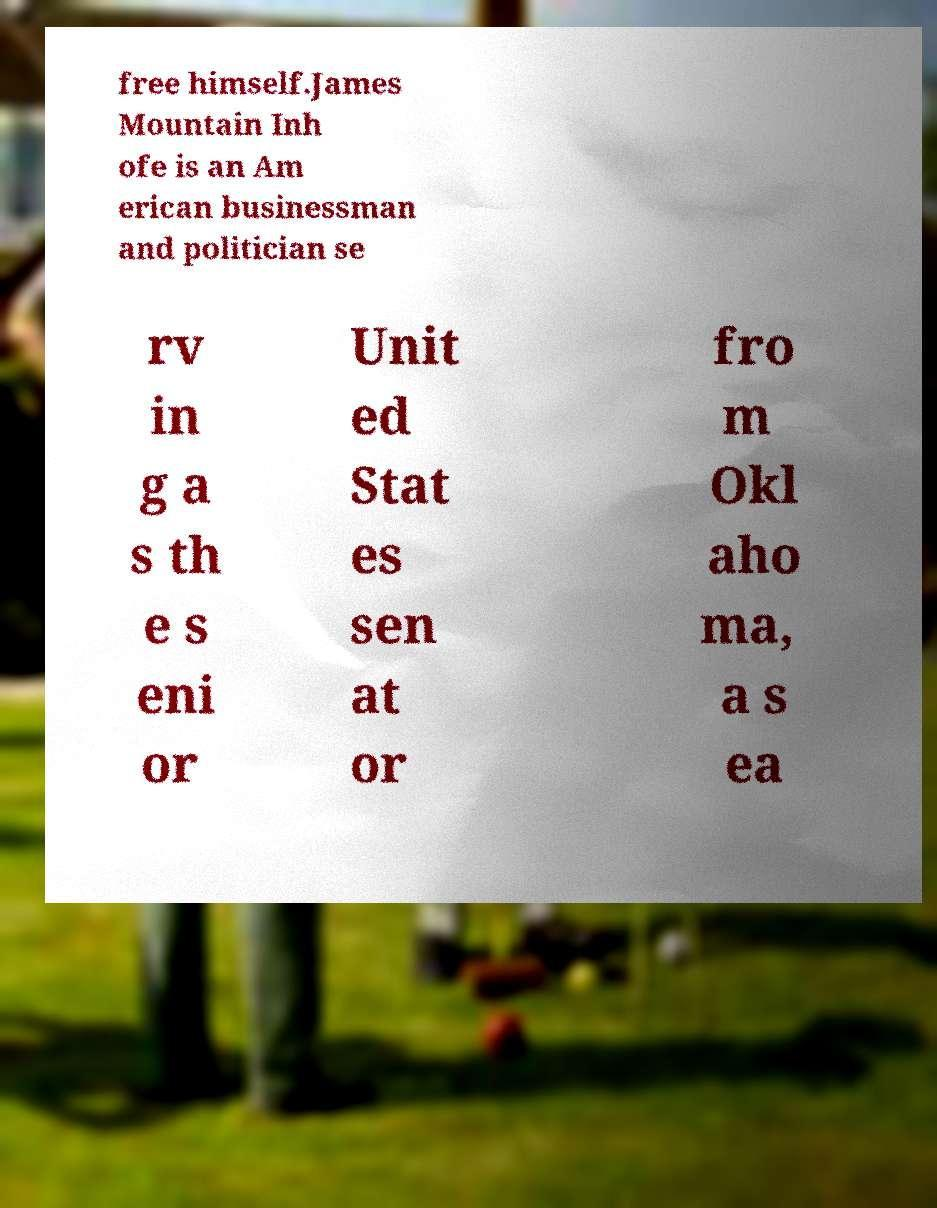I need the written content from this picture converted into text. Can you do that? free himself.James Mountain Inh ofe is an Am erican businessman and politician se rv in g a s th e s eni or Unit ed Stat es sen at or fro m Okl aho ma, a s ea 